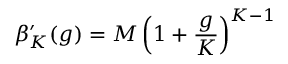<formula> <loc_0><loc_0><loc_500><loc_500>\beta _ { K } ^ { \prime } ( g ) = M \left ( 1 + \frac { g } { K } \right ) ^ { K - 1 }</formula> 